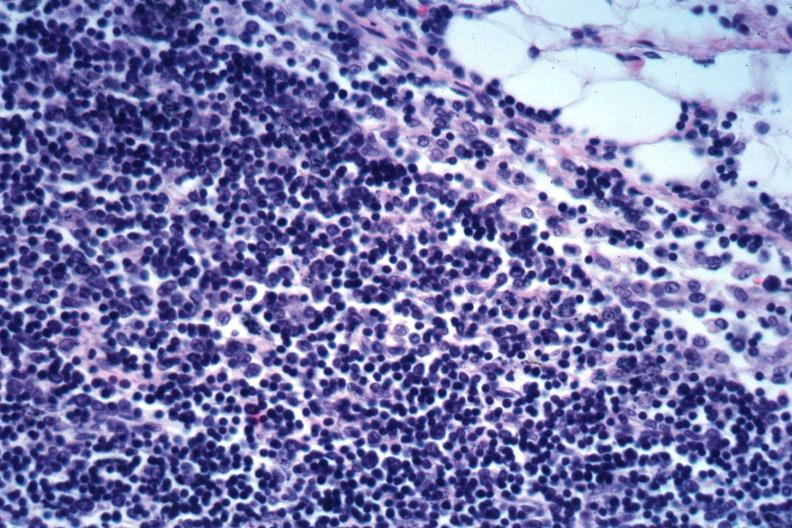s malignant lymphoma present?
Answer the question using a single word or phrase. Yes 